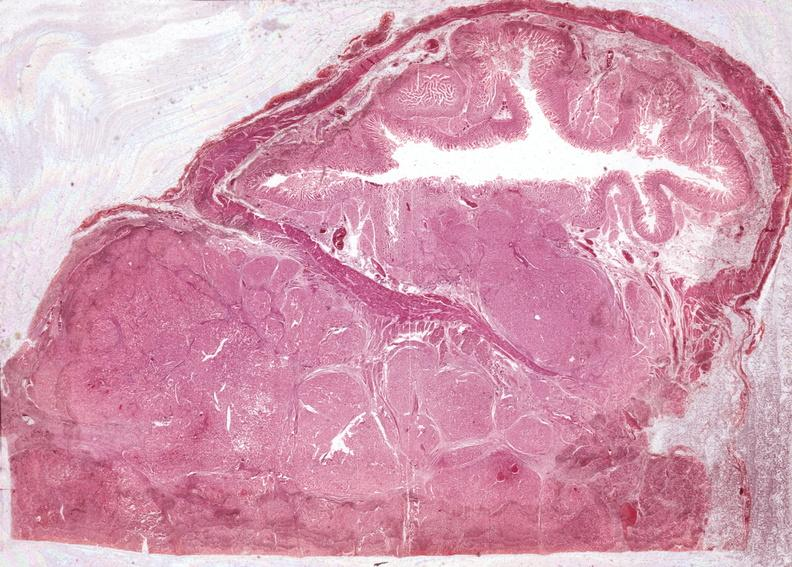does this image show islet cell carcinoma?
Answer the question using a single word or phrase. Yes 